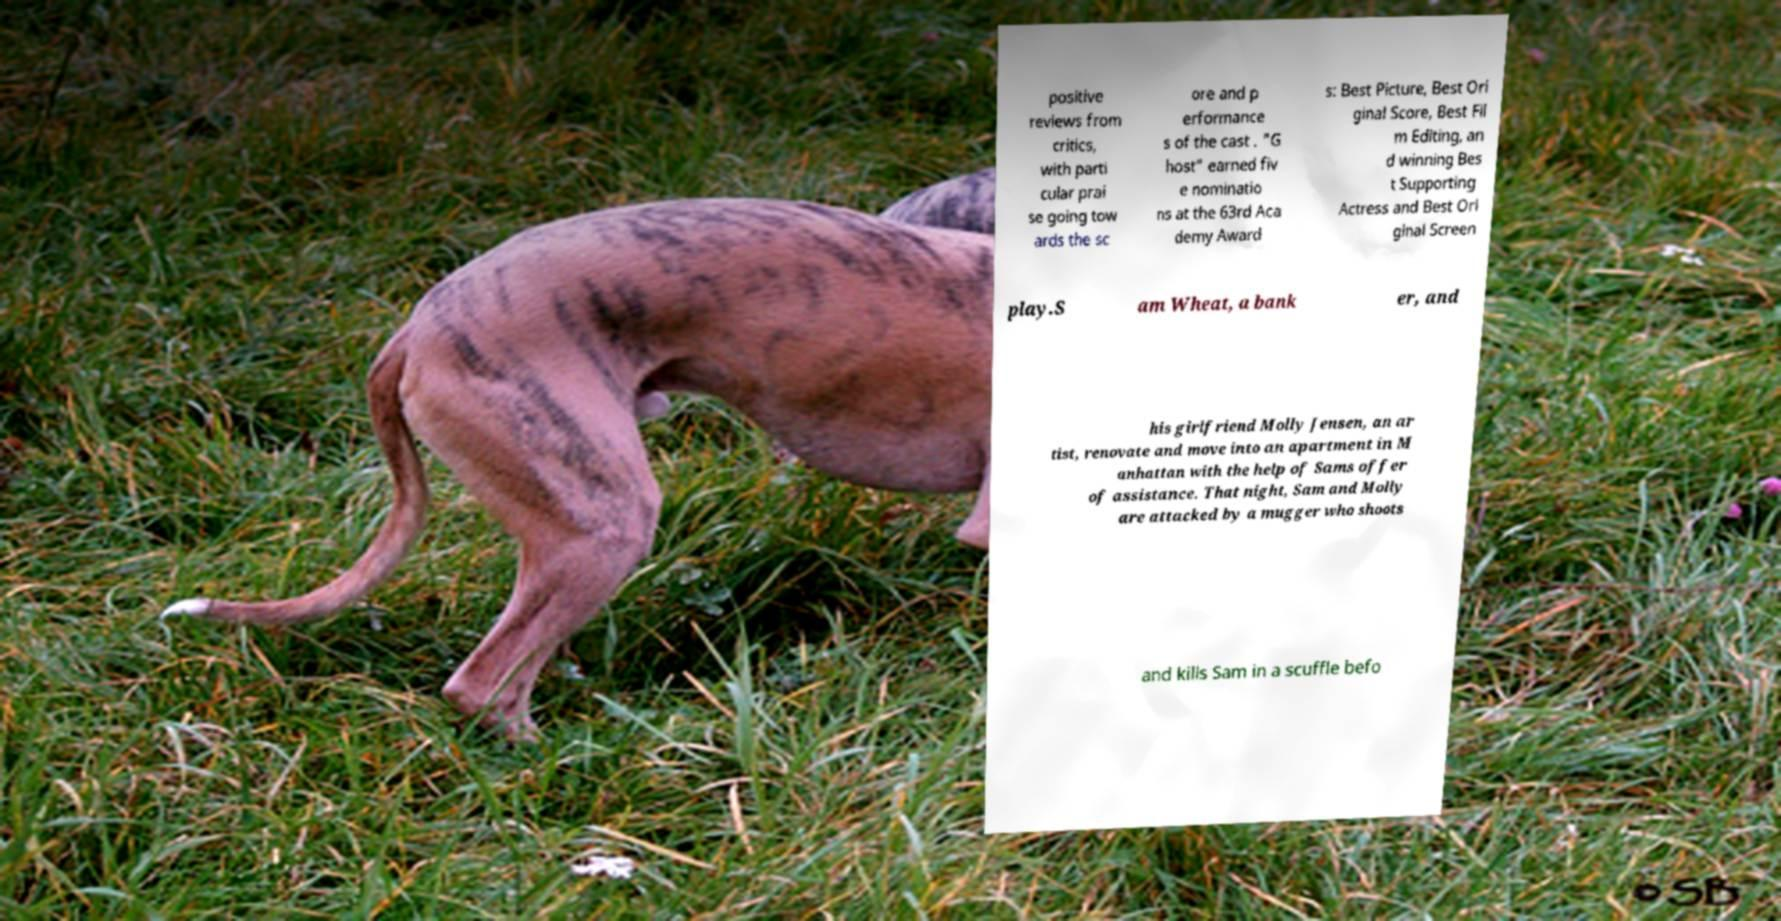Can you accurately transcribe the text from the provided image for me? positive reviews from critics, with parti cular prai se going tow ards the sc ore and p erformance s of the cast . "G host" earned fiv e nominatio ns at the 63rd Aca demy Award s: Best Picture, Best Ori ginal Score, Best Fil m Editing, an d winning Bes t Supporting Actress and Best Ori ginal Screen play.S am Wheat, a bank er, and his girlfriend Molly Jensen, an ar tist, renovate and move into an apartment in M anhattan with the help of Sams offer of assistance. That night, Sam and Molly are attacked by a mugger who shoots and kills Sam in a scuffle befo 